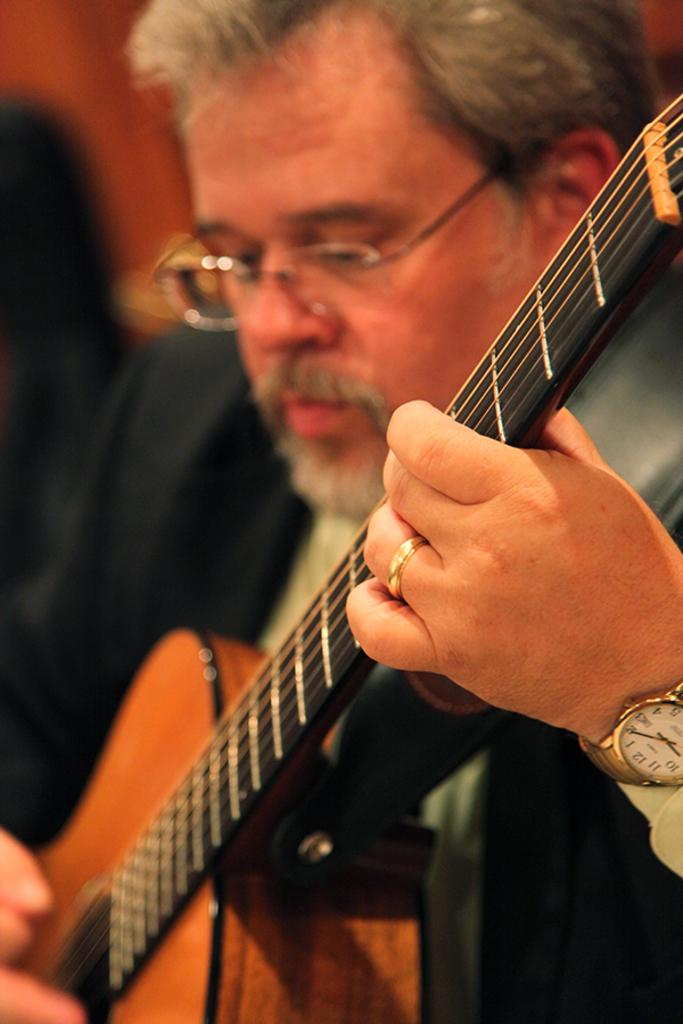What is the man in the image wearing? The man is wearing a black suit. Can you describe the man's hair? The man has white hair. What accessory is the man wearing on his face? The man is wearing spectacles. What is the man doing in the image? The man is playing a guitar. Are there any accessories visible on the man's hands? Yes, there is a watch on the man's left hand and a ring on the man's left hand. What type of juice can be seen in the man's hand in the image? There is no juice present in the image; the man is playing a guitar and wearing a watch and a ring on his left hand. 